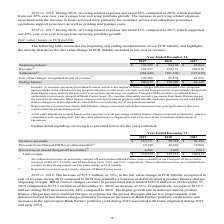From Greensky's financial document, Which years does the table provide? The document contains multiple relevant values: 2019, 2018, 2017. From the document: "Year Ended December 31, 2019 2018 2017 Beginning balance $ 138,589 $ 94,148 $ 68,064 Receipts (1) 159,527 129,153 109,818 Settlements (2) Year Ended D..." Also, What was the amount of Receipts in 2017? According to the financial document, 109,818 (in thousands). The relevant text states: "89 $ 94,148 $ 68,064 Receipts (1) 159,527 129,153 109,818 Settlements (2) (262,449) (181,590) (127,029)..." Also, What was the amount of Settlements in 2019? According to the financial document, (262,449) (in thousands). The relevant text states: "ceipts (1) 159,527 129,153 109,818 Settlements (2) (262,449) (181,590) (127,029)..." Also, How many years did the Fair value changes recognized in cost of revenue exceed $100,000 thousand? Based on the analysis, there are 1 instances. The counting process: 2019. Also, can you calculate: What was the change in the amount of Settlements between 2017 and 2019? Based on the calculation: -262,449-(-127,029), the result is -135420 (in thousands). This is based on the information: "ipts (1) 159,527 129,153 109,818 Settlements (2) (262,449) (181,590) (127,029) ,153 109,818 Settlements (2) (262,449) (181,590) (127,029)..." The key data points involved are: 127,029, 262,449. Also, can you calculate: What was the percentage change in the ending balance between 2017 and 2018? To answer this question, I need to perform calculations using the financial data. The calculation is: (138,589-94,148)/94,148, which equals 47.2 (percentage). This is based on the information: "31, 2019 2018 2017 Beginning balance $ 138,589 $ 94,148 $ 68,064 Receipts (1) 159,527 129,153 109,818 Settlements (2) (262,449) (181,590) (127,029) d December 31, 2019 2018 2017 Beginning balance $ 13..." The key data points involved are: 138,589, 94,148. 